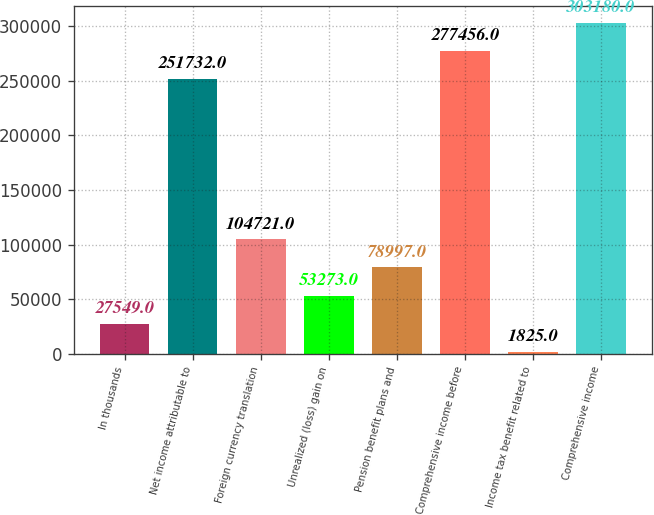Convert chart to OTSL. <chart><loc_0><loc_0><loc_500><loc_500><bar_chart><fcel>In thousands<fcel>Net income attributable to<fcel>Foreign currency translation<fcel>Unrealized (loss) gain on<fcel>Pension benefit plans and<fcel>Comprehensive income before<fcel>Income tax benefit related to<fcel>Comprehensive income<nl><fcel>27549<fcel>251732<fcel>104721<fcel>53273<fcel>78997<fcel>277456<fcel>1825<fcel>303180<nl></chart> 